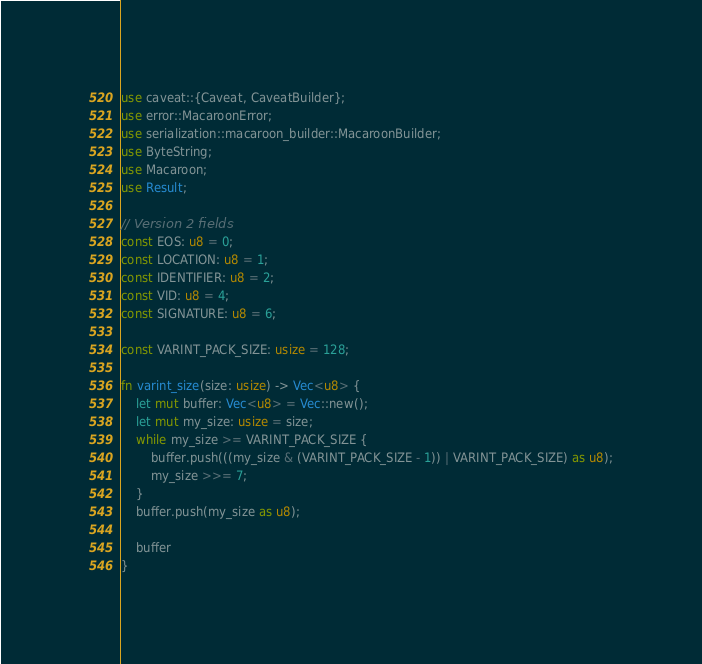<code> <loc_0><loc_0><loc_500><loc_500><_Rust_>use caveat::{Caveat, CaveatBuilder};
use error::MacaroonError;
use serialization::macaroon_builder::MacaroonBuilder;
use ByteString;
use Macaroon;
use Result;

// Version 2 fields
const EOS: u8 = 0;
const LOCATION: u8 = 1;
const IDENTIFIER: u8 = 2;
const VID: u8 = 4;
const SIGNATURE: u8 = 6;

const VARINT_PACK_SIZE: usize = 128;

fn varint_size(size: usize) -> Vec<u8> {
    let mut buffer: Vec<u8> = Vec::new();
    let mut my_size: usize = size;
    while my_size >= VARINT_PACK_SIZE {
        buffer.push(((my_size & (VARINT_PACK_SIZE - 1)) | VARINT_PACK_SIZE) as u8);
        my_size >>= 7;
    }
    buffer.push(my_size as u8);

    buffer
}
</code> 